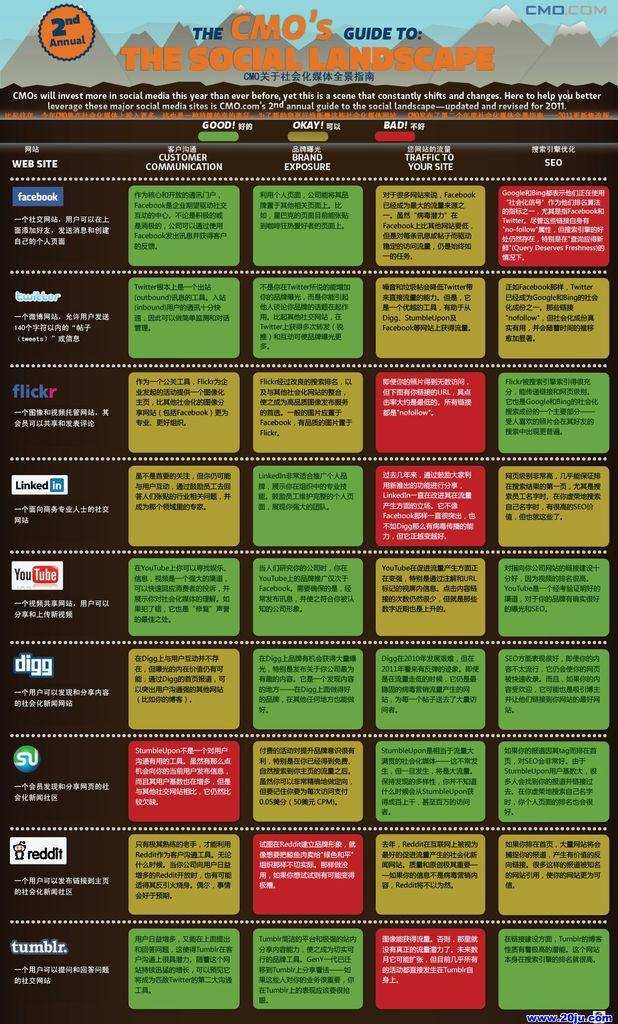<image>
Write a terse but informative summary of the picture. A poster is labelled as the CMO's guide to the social landscape. 